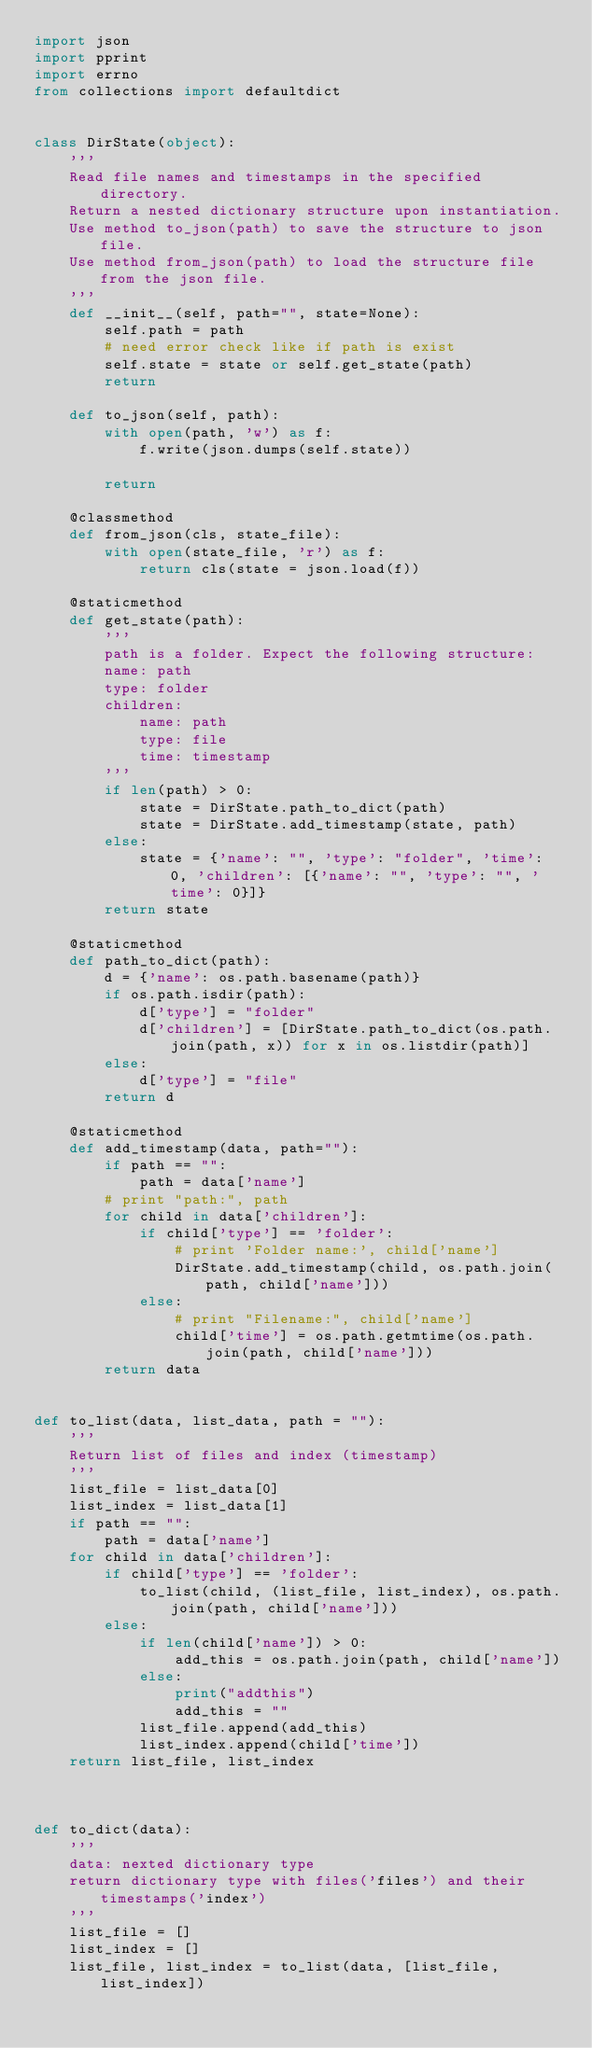<code> <loc_0><loc_0><loc_500><loc_500><_Python_>import json
import pprint
import errno
from collections import defaultdict


class DirState(object):
    '''
    Read file names and timestamps in the specified directory.
    Return a nested dictionary structure upon instantiation.
    Use method to_json(path) to save the structure to json file.
    Use method from_json(path) to load the structure file from the json file.
    '''
    def __init__(self, path="", state=None):
        self.path = path
        # need error check like if path is exist
        self.state = state or self.get_state(path)
        return

    def to_json(self, path):
        with open(path, 'w') as f:
            f.write(json.dumps(self.state))

        return

    @classmethod
    def from_json(cls, state_file):
        with open(state_file, 'r') as f:
            return cls(state = json.load(f))

    @staticmethod
    def get_state(path):
        '''
        path is a folder. Expect the following structure:
        name: path
        type: folder
        children:
            name: path
            type: file
            time: timestamp
        '''
        if len(path) > 0:
            state = DirState.path_to_dict(path)
            state = DirState.add_timestamp(state, path)
        else:
            state = {'name': "", 'type': "folder", 'time': 0, 'children': [{'name': "", 'type': "", 'time': 0}]}
        return state

    @staticmethod
    def path_to_dict(path):
        d = {'name': os.path.basename(path)}
        if os.path.isdir(path):
            d['type'] = "folder"
            d['children'] = [DirState.path_to_dict(os.path.join(path, x)) for x in os.listdir(path)]
        else:
            d['type'] = "file"
        return d

    @staticmethod
    def add_timestamp(data, path=""):
        if path == "":
            path = data['name']
        # print "path:", path
        for child in data['children']:
            if child['type'] == 'folder':
                # print 'Folder name:', child['name']
                DirState.add_timestamp(child, os.path.join(path, child['name']))
            else:
                # print "Filename:", child['name']
                child['time'] = os.path.getmtime(os.path.join(path, child['name']))
        return data


def to_list(data, list_data, path = ""):
    '''
    Return list of files and index (timestamp)
    '''
    list_file = list_data[0]
    list_index = list_data[1]
    if path == "":
        path = data['name']
    for child in data['children']:
        if child['type'] == 'folder':
            to_list(child, (list_file, list_index), os.path.join(path, child['name']))
        else:
            if len(child['name']) > 0:
                add_this = os.path.join(path, child['name'])
            else:
                print("addthis")
                add_this = ""
            list_file.append(add_this)
            list_index.append(child['time'])
    return list_file, list_index



def to_dict(data):
    '''
    data: nexted dictionary type
    return dictionary type with files('files') and their timestamps('index')
    '''
    list_file = []
    list_index = []
    list_file, list_index = to_list(data, [list_file, list_index])</code> 